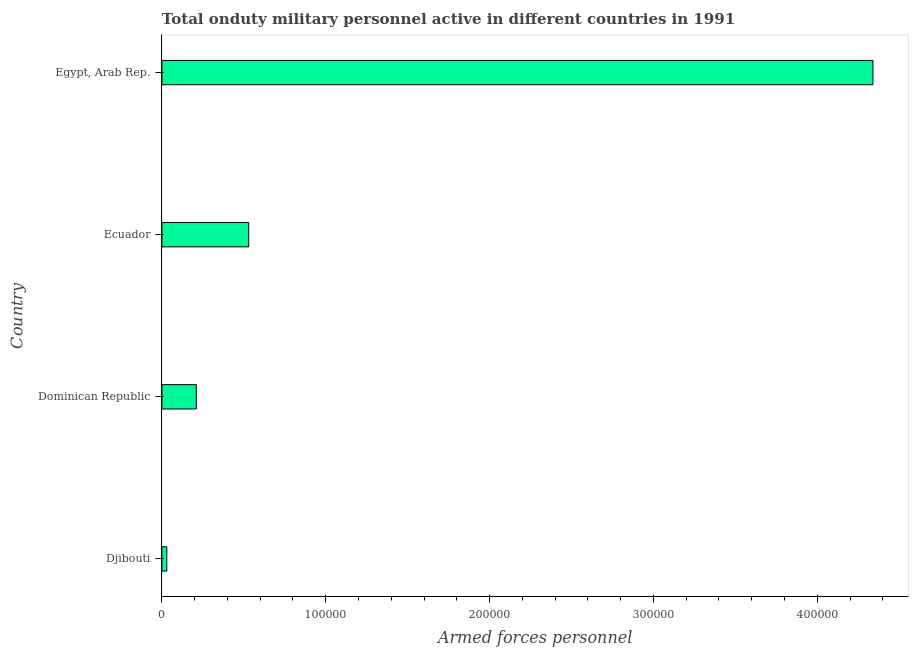What is the title of the graph?
Provide a succinct answer. Total onduty military personnel active in different countries in 1991. What is the label or title of the X-axis?
Your response must be concise. Armed forces personnel. What is the number of armed forces personnel in Ecuador?
Offer a very short reply. 5.30e+04. Across all countries, what is the maximum number of armed forces personnel?
Ensure brevity in your answer.  4.34e+05. Across all countries, what is the minimum number of armed forces personnel?
Give a very brief answer. 3000. In which country was the number of armed forces personnel maximum?
Offer a terse response. Egypt, Arab Rep. In which country was the number of armed forces personnel minimum?
Provide a short and direct response. Djibouti. What is the sum of the number of armed forces personnel?
Your answer should be very brief. 5.11e+05. What is the difference between the number of armed forces personnel in Ecuador and Egypt, Arab Rep.?
Give a very brief answer. -3.81e+05. What is the average number of armed forces personnel per country?
Your answer should be compact. 1.28e+05. What is the median number of armed forces personnel?
Offer a very short reply. 3.70e+04. In how many countries, is the number of armed forces personnel greater than 380000 ?
Provide a short and direct response. 1. What is the ratio of the number of armed forces personnel in Dominican Republic to that in Ecuador?
Offer a terse response. 0.4. Is the number of armed forces personnel in Dominican Republic less than that in Ecuador?
Give a very brief answer. Yes. Is the difference between the number of armed forces personnel in Djibouti and Dominican Republic greater than the difference between any two countries?
Provide a short and direct response. No. What is the difference between the highest and the second highest number of armed forces personnel?
Make the answer very short. 3.81e+05. Is the sum of the number of armed forces personnel in Dominican Republic and Egypt, Arab Rep. greater than the maximum number of armed forces personnel across all countries?
Provide a succinct answer. Yes. What is the difference between the highest and the lowest number of armed forces personnel?
Your answer should be compact. 4.31e+05. In how many countries, is the number of armed forces personnel greater than the average number of armed forces personnel taken over all countries?
Offer a very short reply. 1. Are the values on the major ticks of X-axis written in scientific E-notation?
Your answer should be very brief. No. What is the Armed forces personnel in Djibouti?
Offer a very short reply. 3000. What is the Armed forces personnel in Dominican Republic?
Make the answer very short. 2.10e+04. What is the Armed forces personnel of Ecuador?
Your answer should be compact. 5.30e+04. What is the Armed forces personnel of Egypt, Arab Rep.?
Your answer should be compact. 4.34e+05. What is the difference between the Armed forces personnel in Djibouti and Dominican Republic?
Keep it short and to the point. -1.80e+04. What is the difference between the Armed forces personnel in Djibouti and Ecuador?
Provide a succinct answer. -5.00e+04. What is the difference between the Armed forces personnel in Djibouti and Egypt, Arab Rep.?
Offer a very short reply. -4.31e+05. What is the difference between the Armed forces personnel in Dominican Republic and Ecuador?
Provide a succinct answer. -3.20e+04. What is the difference between the Armed forces personnel in Dominican Republic and Egypt, Arab Rep.?
Give a very brief answer. -4.13e+05. What is the difference between the Armed forces personnel in Ecuador and Egypt, Arab Rep.?
Offer a terse response. -3.81e+05. What is the ratio of the Armed forces personnel in Djibouti to that in Dominican Republic?
Make the answer very short. 0.14. What is the ratio of the Armed forces personnel in Djibouti to that in Ecuador?
Your answer should be compact. 0.06. What is the ratio of the Armed forces personnel in Djibouti to that in Egypt, Arab Rep.?
Your response must be concise. 0.01. What is the ratio of the Armed forces personnel in Dominican Republic to that in Ecuador?
Your answer should be compact. 0.4. What is the ratio of the Armed forces personnel in Dominican Republic to that in Egypt, Arab Rep.?
Provide a short and direct response. 0.05. What is the ratio of the Armed forces personnel in Ecuador to that in Egypt, Arab Rep.?
Your answer should be very brief. 0.12. 